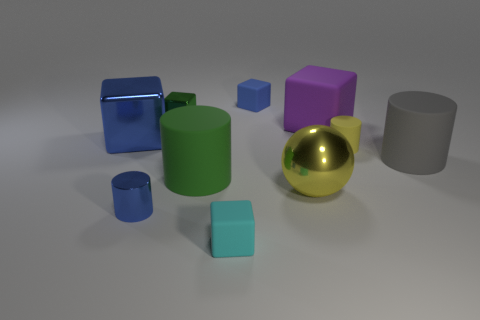Subtract all yellow cylinders. How many cylinders are left? 3 Subtract 4 cubes. How many cubes are left? 1 Subtract all purple cubes. Subtract all blue cylinders. How many cubes are left? 4 Subtract all yellow spheres. How many brown blocks are left? 0 Subtract all tiny cyan cubes. Subtract all purple objects. How many objects are left? 8 Add 2 big rubber things. How many big rubber things are left? 5 Add 3 matte cubes. How many matte cubes exist? 6 Subtract all yellow rubber cylinders. How many cylinders are left? 3 Subtract 0 cyan balls. How many objects are left? 10 Subtract all spheres. How many objects are left? 9 